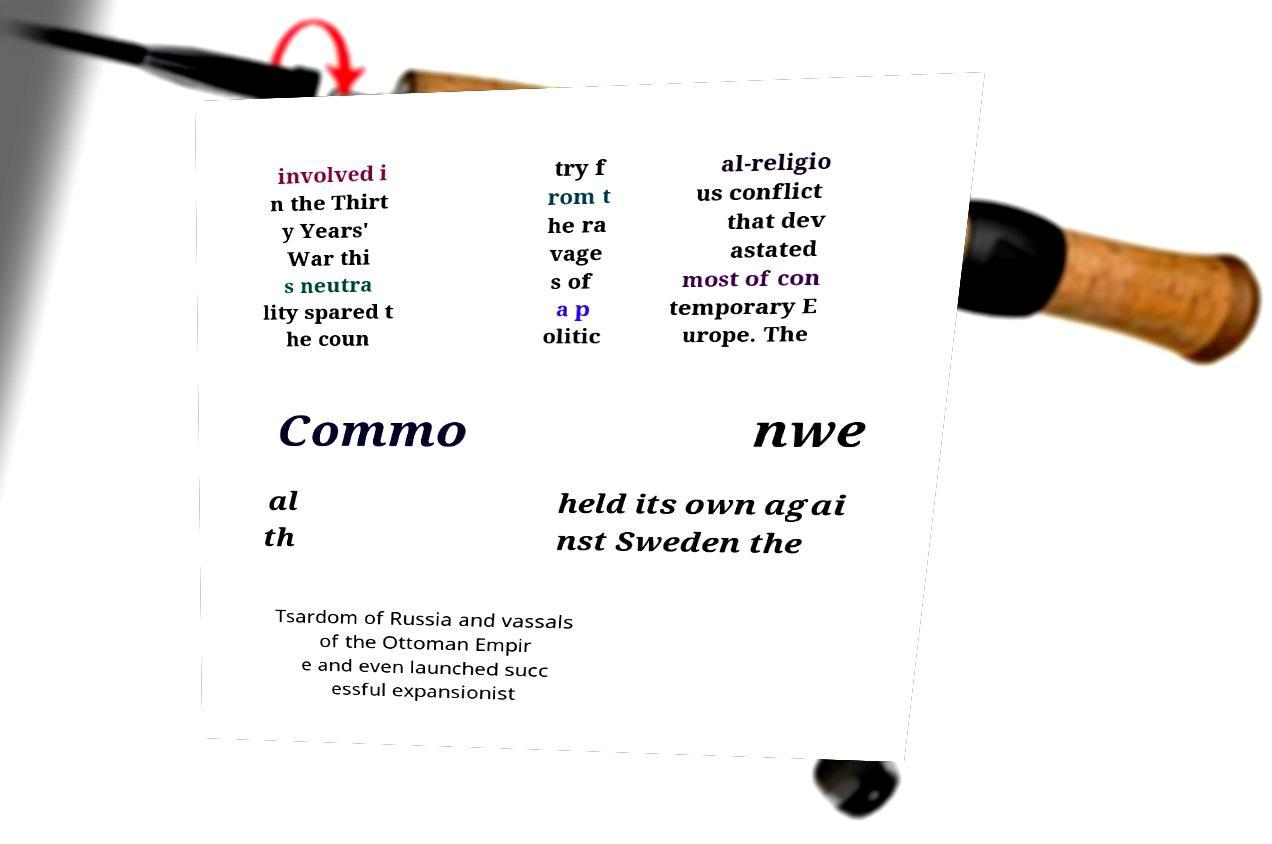There's text embedded in this image that I need extracted. Can you transcribe it verbatim? involved i n the Thirt y Years' War thi s neutra lity spared t he coun try f rom t he ra vage s of a p olitic al-religio us conflict that dev astated most of con temporary E urope. The Commo nwe al th held its own agai nst Sweden the Tsardom of Russia and vassals of the Ottoman Empir e and even launched succ essful expansionist 